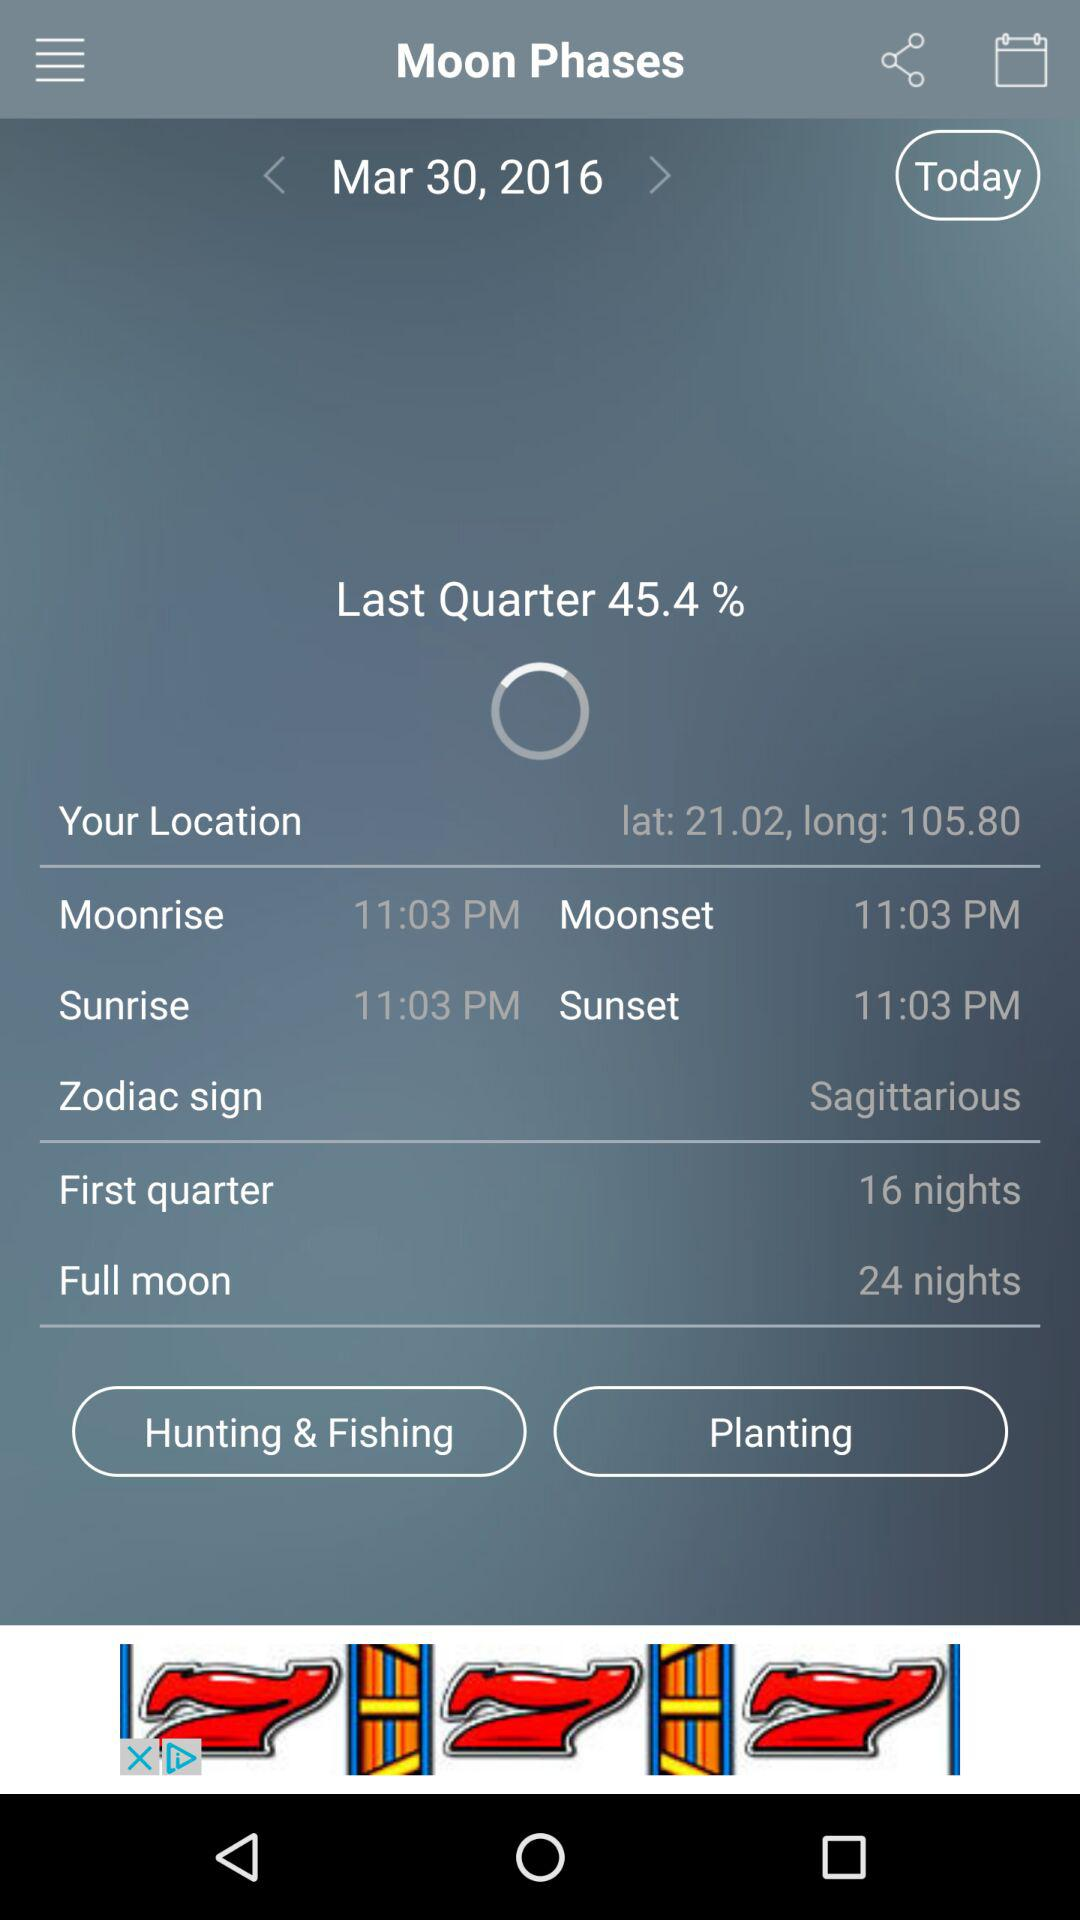What are the latitudes and longitudes? The latitudes and longitudes are 21.02 and 105.80, respectively. 